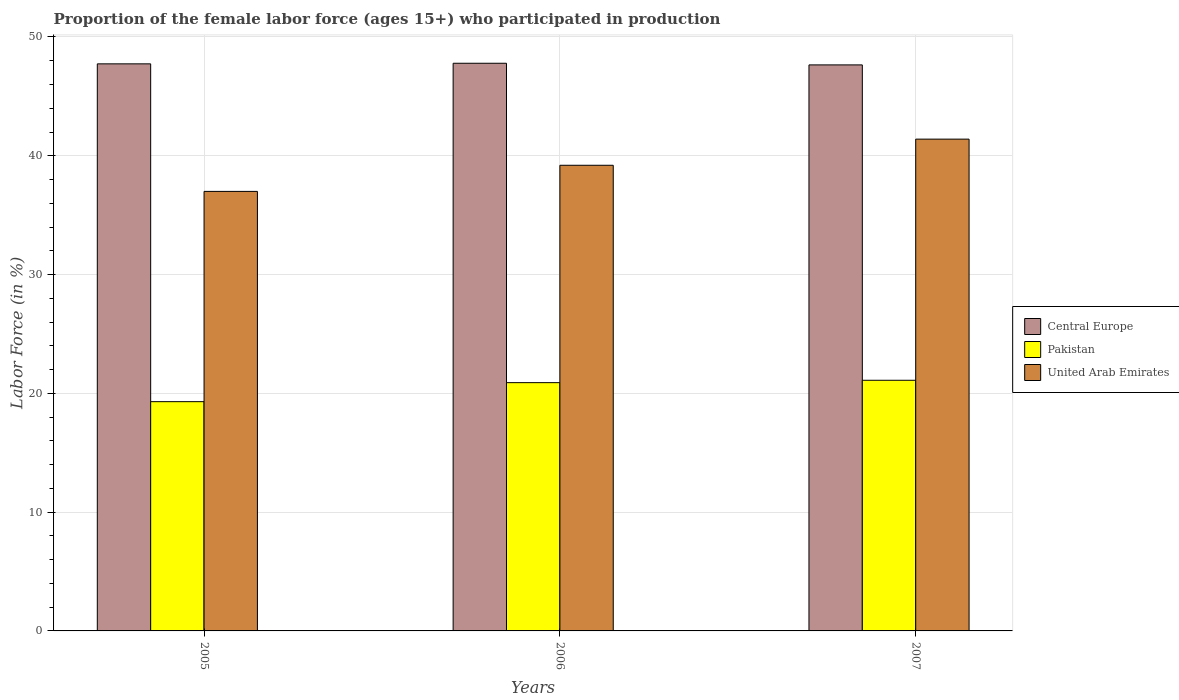How many bars are there on the 2nd tick from the left?
Offer a terse response. 3. How many bars are there on the 3rd tick from the right?
Provide a succinct answer. 3. In how many cases, is the number of bars for a given year not equal to the number of legend labels?
Make the answer very short. 0. What is the proportion of the female labor force who participated in production in Central Europe in 2007?
Provide a short and direct response. 47.65. Across all years, what is the maximum proportion of the female labor force who participated in production in Central Europe?
Make the answer very short. 47.79. Across all years, what is the minimum proportion of the female labor force who participated in production in United Arab Emirates?
Your response must be concise. 37. In which year was the proportion of the female labor force who participated in production in Pakistan maximum?
Make the answer very short. 2007. What is the total proportion of the female labor force who participated in production in Pakistan in the graph?
Keep it short and to the point. 61.3. What is the difference between the proportion of the female labor force who participated in production in Central Europe in 2005 and that in 2006?
Your response must be concise. -0.05. What is the difference between the proportion of the female labor force who participated in production in United Arab Emirates in 2007 and the proportion of the female labor force who participated in production in Central Europe in 2006?
Offer a very short reply. -6.39. What is the average proportion of the female labor force who participated in production in Central Europe per year?
Your answer should be very brief. 47.72. In the year 2006, what is the difference between the proportion of the female labor force who participated in production in United Arab Emirates and proportion of the female labor force who participated in production in Central Europe?
Your answer should be compact. -8.59. In how many years, is the proportion of the female labor force who participated in production in Pakistan greater than 10 %?
Provide a succinct answer. 3. What is the ratio of the proportion of the female labor force who participated in production in Pakistan in 2005 to that in 2007?
Your answer should be very brief. 0.91. Is the proportion of the female labor force who participated in production in United Arab Emirates in 2006 less than that in 2007?
Provide a short and direct response. Yes. What is the difference between the highest and the second highest proportion of the female labor force who participated in production in Pakistan?
Your answer should be compact. 0.2. What is the difference between the highest and the lowest proportion of the female labor force who participated in production in Central Europe?
Offer a terse response. 0.14. Is the sum of the proportion of the female labor force who participated in production in Central Europe in 2006 and 2007 greater than the maximum proportion of the female labor force who participated in production in Pakistan across all years?
Your answer should be compact. Yes. What does the 1st bar from the left in 2007 represents?
Provide a succinct answer. Central Europe. What does the 3rd bar from the right in 2007 represents?
Your response must be concise. Central Europe. How many bars are there?
Offer a very short reply. 9. Are all the bars in the graph horizontal?
Your response must be concise. No. What is the difference between two consecutive major ticks on the Y-axis?
Your response must be concise. 10. Are the values on the major ticks of Y-axis written in scientific E-notation?
Your answer should be very brief. No. Where does the legend appear in the graph?
Make the answer very short. Center right. How many legend labels are there?
Make the answer very short. 3. How are the legend labels stacked?
Your answer should be compact. Vertical. What is the title of the graph?
Provide a short and direct response. Proportion of the female labor force (ages 15+) who participated in production. What is the label or title of the X-axis?
Your answer should be compact. Years. What is the label or title of the Y-axis?
Ensure brevity in your answer.  Labor Force (in %). What is the Labor Force (in %) of Central Europe in 2005?
Ensure brevity in your answer.  47.74. What is the Labor Force (in %) of Pakistan in 2005?
Offer a very short reply. 19.3. What is the Labor Force (in %) of United Arab Emirates in 2005?
Provide a short and direct response. 37. What is the Labor Force (in %) in Central Europe in 2006?
Make the answer very short. 47.79. What is the Labor Force (in %) in Pakistan in 2006?
Ensure brevity in your answer.  20.9. What is the Labor Force (in %) of United Arab Emirates in 2006?
Provide a succinct answer. 39.2. What is the Labor Force (in %) of Central Europe in 2007?
Your answer should be very brief. 47.65. What is the Labor Force (in %) of Pakistan in 2007?
Your answer should be very brief. 21.1. What is the Labor Force (in %) of United Arab Emirates in 2007?
Your answer should be compact. 41.4. Across all years, what is the maximum Labor Force (in %) in Central Europe?
Make the answer very short. 47.79. Across all years, what is the maximum Labor Force (in %) of Pakistan?
Offer a very short reply. 21.1. Across all years, what is the maximum Labor Force (in %) in United Arab Emirates?
Make the answer very short. 41.4. Across all years, what is the minimum Labor Force (in %) in Central Europe?
Offer a very short reply. 47.65. Across all years, what is the minimum Labor Force (in %) of Pakistan?
Make the answer very short. 19.3. What is the total Labor Force (in %) of Central Europe in the graph?
Your answer should be very brief. 143.17. What is the total Labor Force (in %) of Pakistan in the graph?
Your answer should be very brief. 61.3. What is the total Labor Force (in %) in United Arab Emirates in the graph?
Ensure brevity in your answer.  117.6. What is the difference between the Labor Force (in %) of Central Europe in 2005 and that in 2006?
Provide a short and direct response. -0.05. What is the difference between the Labor Force (in %) of Central Europe in 2005 and that in 2007?
Keep it short and to the point. 0.09. What is the difference between the Labor Force (in %) of Central Europe in 2006 and that in 2007?
Provide a short and direct response. 0.14. What is the difference between the Labor Force (in %) in United Arab Emirates in 2006 and that in 2007?
Your answer should be compact. -2.2. What is the difference between the Labor Force (in %) of Central Europe in 2005 and the Labor Force (in %) of Pakistan in 2006?
Keep it short and to the point. 26.84. What is the difference between the Labor Force (in %) of Central Europe in 2005 and the Labor Force (in %) of United Arab Emirates in 2006?
Keep it short and to the point. 8.54. What is the difference between the Labor Force (in %) of Pakistan in 2005 and the Labor Force (in %) of United Arab Emirates in 2006?
Make the answer very short. -19.9. What is the difference between the Labor Force (in %) in Central Europe in 2005 and the Labor Force (in %) in Pakistan in 2007?
Your answer should be very brief. 26.64. What is the difference between the Labor Force (in %) of Central Europe in 2005 and the Labor Force (in %) of United Arab Emirates in 2007?
Ensure brevity in your answer.  6.34. What is the difference between the Labor Force (in %) of Pakistan in 2005 and the Labor Force (in %) of United Arab Emirates in 2007?
Offer a very short reply. -22.1. What is the difference between the Labor Force (in %) in Central Europe in 2006 and the Labor Force (in %) in Pakistan in 2007?
Your answer should be compact. 26.69. What is the difference between the Labor Force (in %) of Central Europe in 2006 and the Labor Force (in %) of United Arab Emirates in 2007?
Give a very brief answer. 6.39. What is the difference between the Labor Force (in %) in Pakistan in 2006 and the Labor Force (in %) in United Arab Emirates in 2007?
Provide a succinct answer. -20.5. What is the average Labor Force (in %) of Central Europe per year?
Your response must be concise. 47.72. What is the average Labor Force (in %) in Pakistan per year?
Provide a short and direct response. 20.43. What is the average Labor Force (in %) of United Arab Emirates per year?
Your answer should be compact. 39.2. In the year 2005, what is the difference between the Labor Force (in %) of Central Europe and Labor Force (in %) of Pakistan?
Offer a terse response. 28.44. In the year 2005, what is the difference between the Labor Force (in %) in Central Europe and Labor Force (in %) in United Arab Emirates?
Your answer should be compact. 10.74. In the year 2005, what is the difference between the Labor Force (in %) in Pakistan and Labor Force (in %) in United Arab Emirates?
Your response must be concise. -17.7. In the year 2006, what is the difference between the Labor Force (in %) of Central Europe and Labor Force (in %) of Pakistan?
Offer a very short reply. 26.89. In the year 2006, what is the difference between the Labor Force (in %) in Central Europe and Labor Force (in %) in United Arab Emirates?
Your answer should be very brief. 8.59. In the year 2006, what is the difference between the Labor Force (in %) of Pakistan and Labor Force (in %) of United Arab Emirates?
Ensure brevity in your answer.  -18.3. In the year 2007, what is the difference between the Labor Force (in %) in Central Europe and Labor Force (in %) in Pakistan?
Offer a very short reply. 26.55. In the year 2007, what is the difference between the Labor Force (in %) in Central Europe and Labor Force (in %) in United Arab Emirates?
Provide a short and direct response. 6.25. In the year 2007, what is the difference between the Labor Force (in %) of Pakistan and Labor Force (in %) of United Arab Emirates?
Provide a succinct answer. -20.3. What is the ratio of the Labor Force (in %) of Central Europe in 2005 to that in 2006?
Ensure brevity in your answer.  1. What is the ratio of the Labor Force (in %) in Pakistan in 2005 to that in 2006?
Ensure brevity in your answer.  0.92. What is the ratio of the Labor Force (in %) of United Arab Emirates in 2005 to that in 2006?
Offer a very short reply. 0.94. What is the ratio of the Labor Force (in %) of Central Europe in 2005 to that in 2007?
Make the answer very short. 1. What is the ratio of the Labor Force (in %) of Pakistan in 2005 to that in 2007?
Give a very brief answer. 0.91. What is the ratio of the Labor Force (in %) in United Arab Emirates in 2005 to that in 2007?
Make the answer very short. 0.89. What is the ratio of the Labor Force (in %) in Central Europe in 2006 to that in 2007?
Your response must be concise. 1. What is the ratio of the Labor Force (in %) in United Arab Emirates in 2006 to that in 2007?
Offer a very short reply. 0.95. What is the difference between the highest and the second highest Labor Force (in %) of Central Europe?
Offer a very short reply. 0.05. What is the difference between the highest and the lowest Labor Force (in %) in Central Europe?
Ensure brevity in your answer.  0.14. What is the difference between the highest and the lowest Labor Force (in %) in United Arab Emirates?
Make the answer very short. 4.4. 